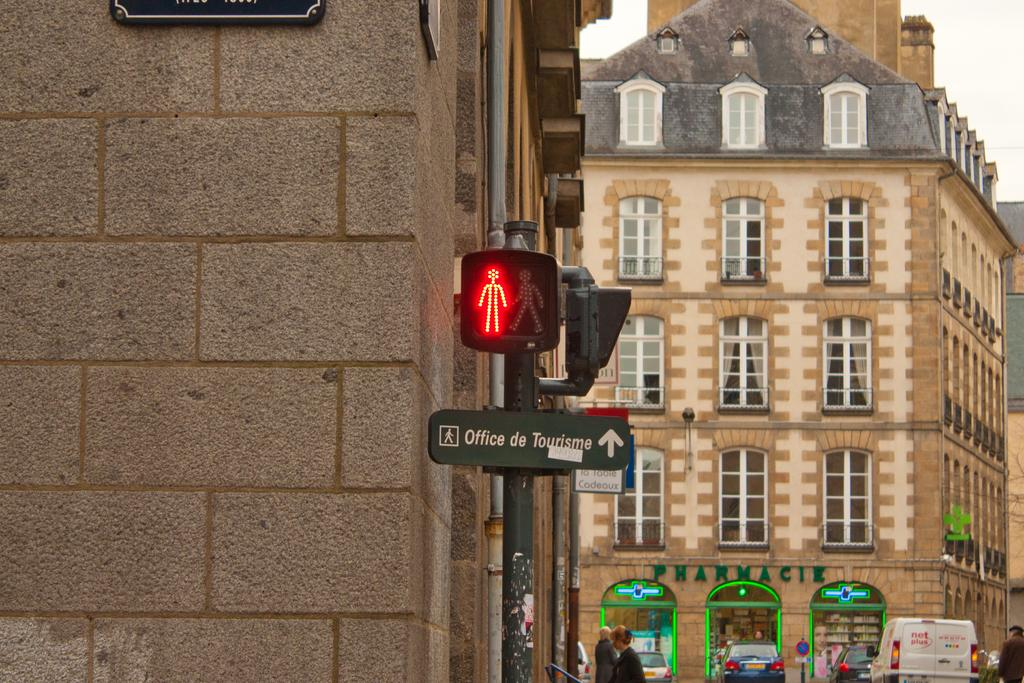<image>
Summarize the visual content of the image. A street sign showing don't walk and a directional arrow to the office of tourism. 